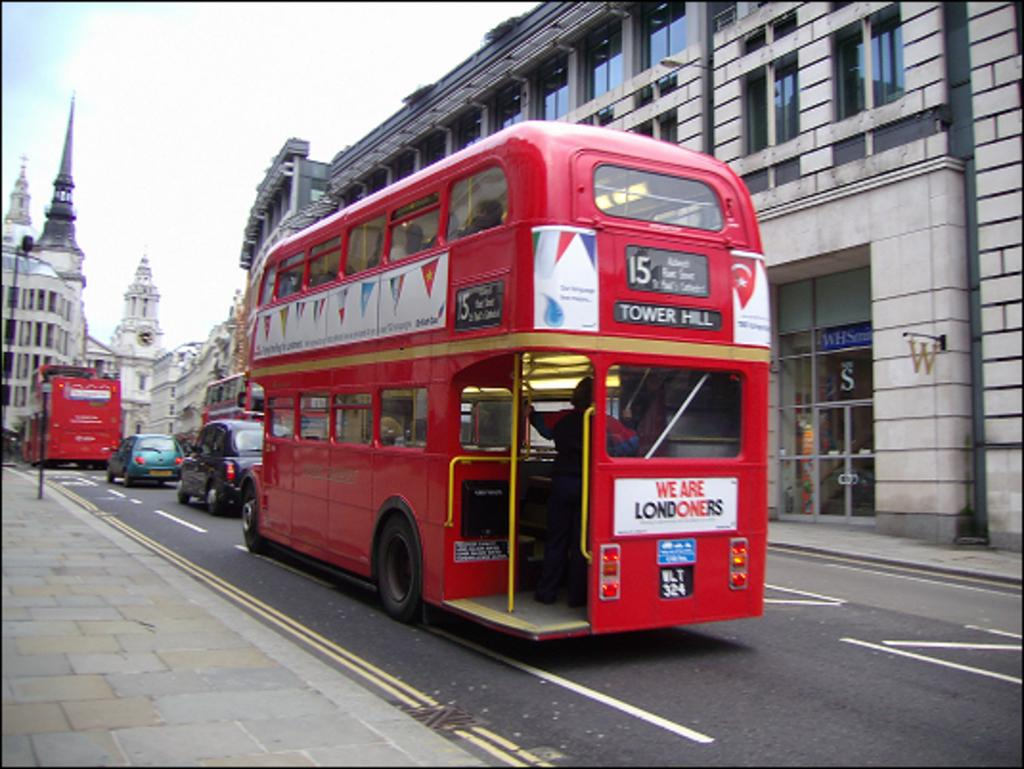<image>
Give a short and clear explanation of the subsequent image. A red double decker tour bus with Tower Hill on it. 